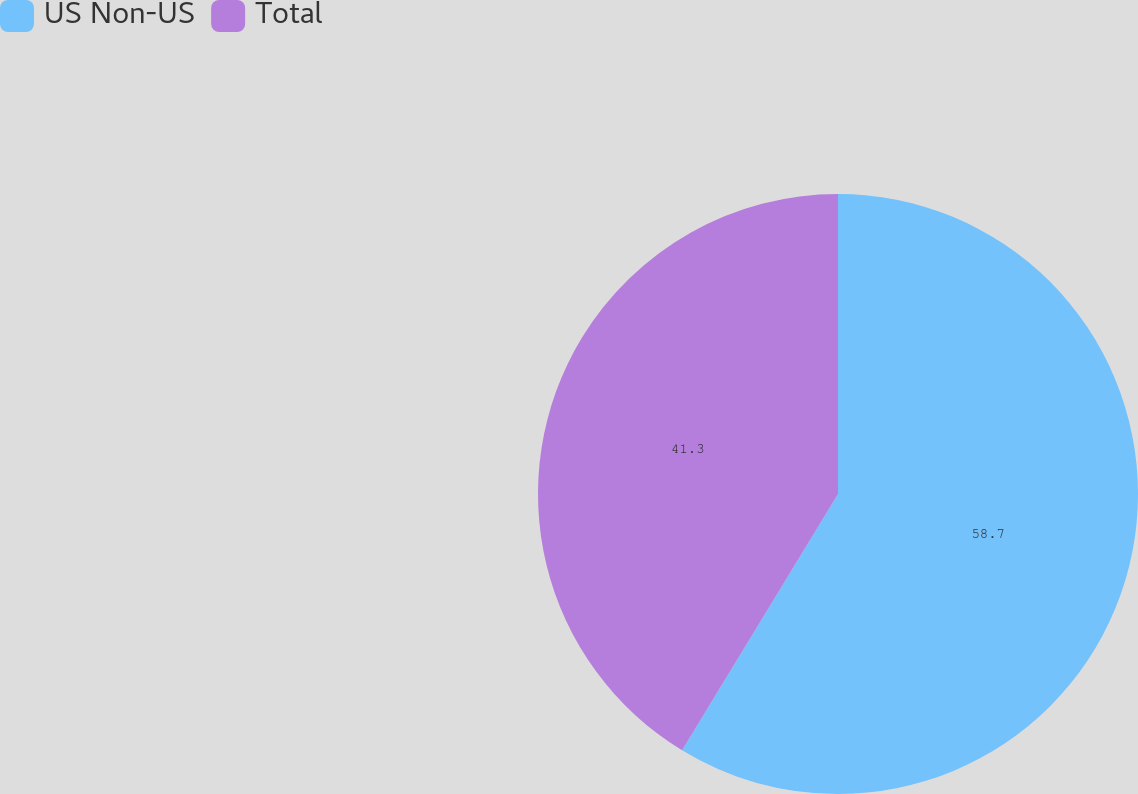Convert chart to OTSL. <chart><loc_0><loc_0><loc_500><loc_500><pie_chart><fcel>US Non-US<fcel>Total<nl><fcel>58.7%<fcel>41.3%<nl></chart> 